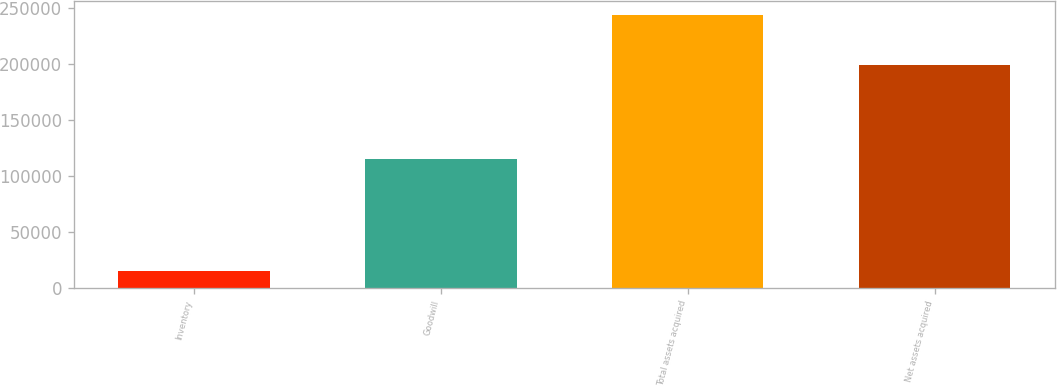Convert chart to OTSL. <chart><loc_0><loc_0><loc_500><loc_500><bar_chart><fcel>Inventory<fcel>Goodwill<fcel>Total assets acquired<fcel>Net assets acquired<nl><fcel>15466<fcel>115448<fcel>243987<fcel>199718<nl></chart> 